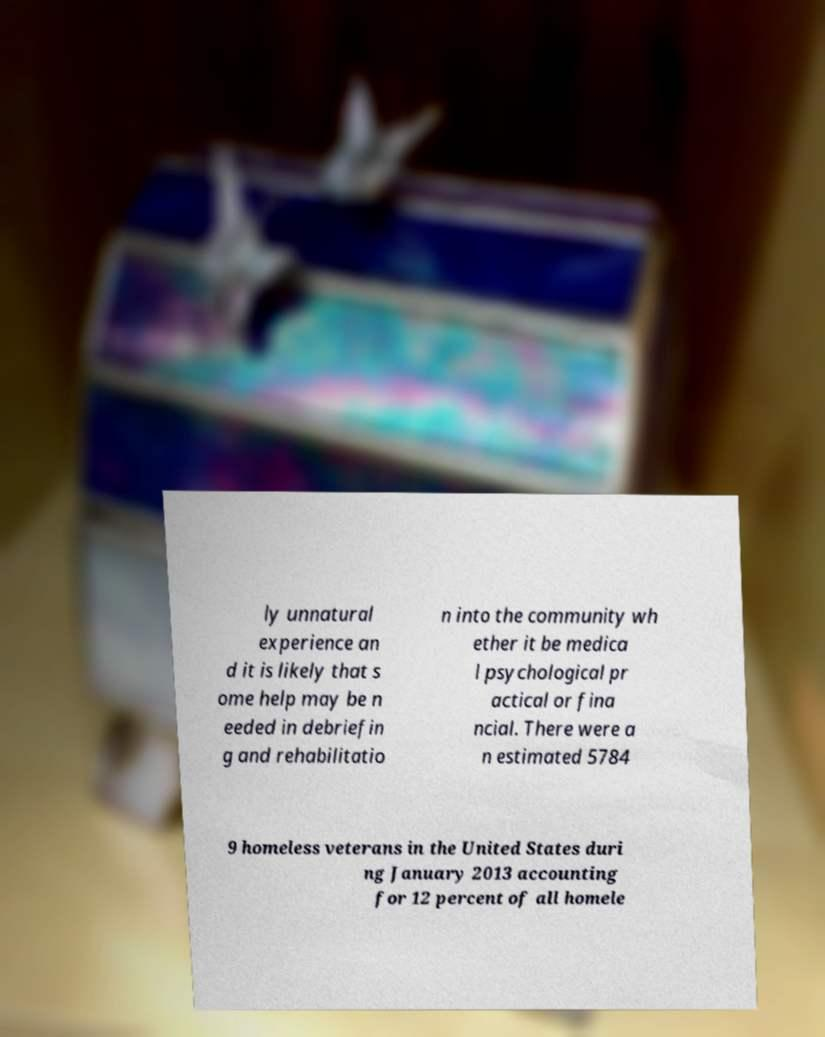Could you extract and type out the text from this image? ly unnatural experience an d it is likely that s ome help may be n eeded in debriefin g and rehabilitatio n into the community wh ether it be medica l psychological pr actical or fina ncial. There were a n estimated 5784 9 homeless veterans in the United States duri ng January 2013 accounting for 12 percent of all homele 